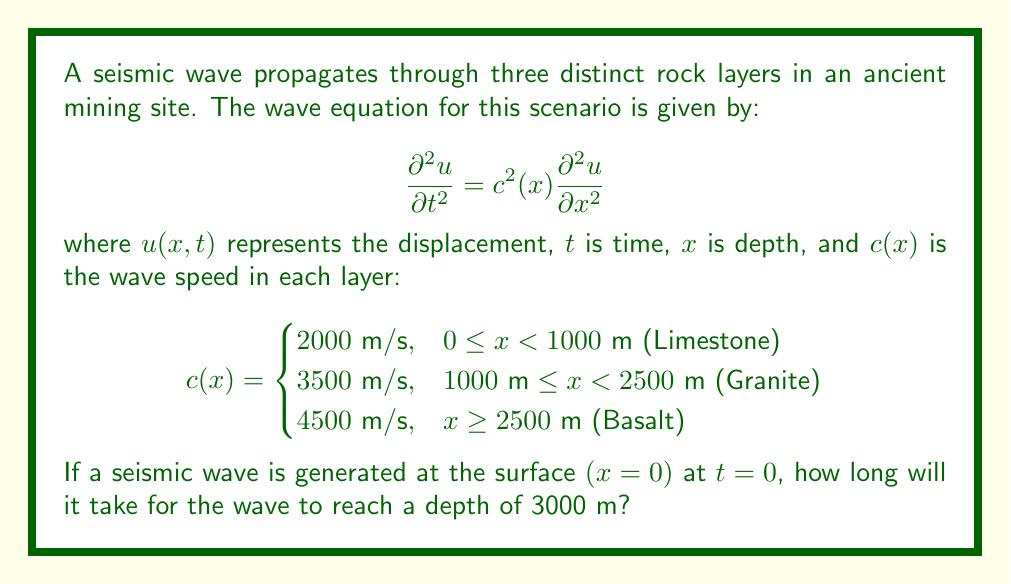What is the answer to this math problem? To solve this problem, we need to calculate the time it takes for the wave to travel through each layer:

1. Limestone layer (0 - 1000 m):
   Time = Distance / Speed
   $t_1 = 1000 \text{ m} / 2000 \text{ m/s} = 0.5 \text{ s}$

2. Granite layer (1000 - 2500 m):
   Distance = 2500 m - 1000 m = 1500 m
   $t_2 = 1500 \text{ m} / 3500 \text{ m/s} \approx 0.4286 \text{ s}$

3. Basalt layer (2500 - 3000 m):
   Distance = 3000 m - 2500 m = 500 m
   $t_3 = 500 \text{ m} / 4500 \text{ m/s} \approx 0.1111 \text{ s}$

Total time:
$t_{total} = t_1 + t_2 + t_3 = 0.5 + 0.4286 + 0.1111 = 1.0397 \text{ s}$
Answer: 1.0397 s 